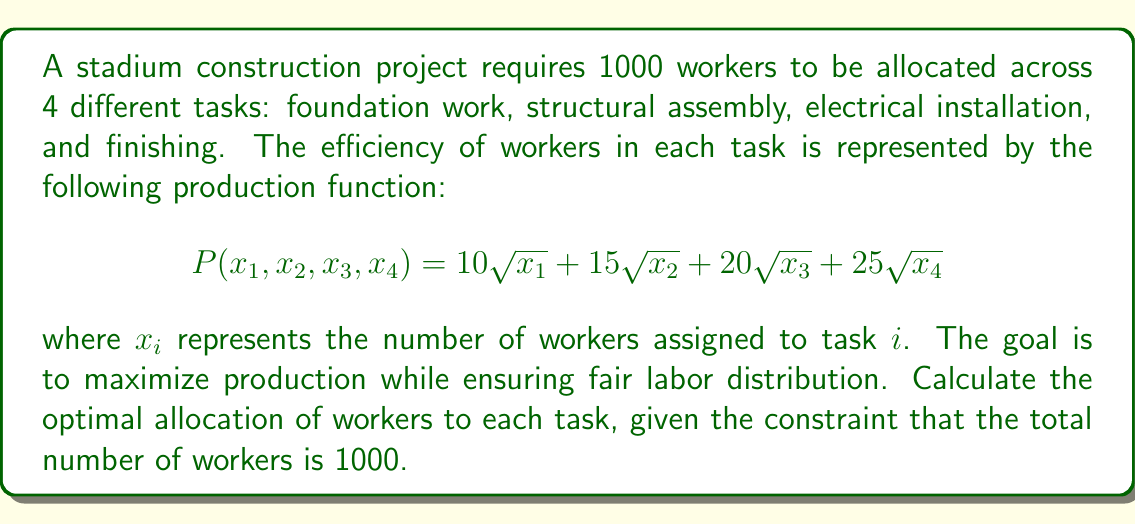Teach me how to tackle this problem. To solve this problem, we'll use the method of Lagrange multipliers, which is ideal for optimizing a function subject to constraints.

1) First, we set up the Lagrangian function:
   $$L(x_1, x_2, x_3, x_4, \lambda) = 10\sqrt{x_1} + 15\sqrt{x_2} + 20\sqrt{x_3} + 25\sqrt{x_4} - \lambda(x_1 + x_2 + x_3 + x_4 - 1000)$$

2) We then take partial derivatives with respect to each variable and set them equal to zero:

   $$\frac{\partial L}{\partial x_1} = \frac{5}{\sqrt{x_1}} - \lambda = 0$$
   $$\frac{\partial L}{\partial x_2} = \frac{15}{2\sqrt{x_2}} - \lambda = 0$$
   $$\frac{\partial L}{\partial x_3} = \frac{10}{\sqrt{x_3}} - \lambda = 0$$
   $$\frac{\partial L}{\partial x_4} = \frac{25}{2\sqrt{x_4}} - \lambda = 0$$
   $$\frac{\partial L}{\partial \lambda} = x_1 + x_2 + x_3 + x_4 - 1000 = 0$$

3) From these equations, we can derive:
   $$x_1 = (\frac{5}{\lambda})^2$$
   $$x_2 = (\frac{15}{2\lambda})^2$$
   $$x_3 = (\frac{10}{\lambda})^2$$
   $$x_4 = (\frac{25}{2\lambda})^2$$

4) Substituting these into the constraint equation:
   $$(\frac{5}{\lambda})^2 + (\frac{15}{2\lambda})^2 + (\frac{10}{\lambda})^2 + (\frac{25}{2\lambda})^2 = 1000$$

5) Simplifying:
   $$\frac{25 + 225/4 + 100 + 625/4}{\lambda^2} = 1000$$
   $$\frac{850}{\lambda^2} = 1000$$
   $$\lambda^2 = \frac{17}{20}$$
   $$\lambda = \frac{\sqrt{17}}{2\sqrt{5}}$$

6) Now we can calculate the optimal values:
   $$x_1 = (\frac{5}{\lambda})^2 = (\frac{10\sqrt{5}}{\sqrt{17}})^2 = \frac{500}{17} \approx 29.41$$
   $$x_2 = (\frac{15}{2\lambda})^2 = (\frac{15\sqrt{5}}{\sqrt{17}})^2 = \frac{1125}{17} \approx 66.18$$
   $$x_3 = (\frac{10}{\lambda})^2 = (\frac{20\sqrt{5}}{\sqrt{17}})^2 = \frac{2000}{17} \approx 117.65$$
   $$x_4 = (\frac{25}{2\lambda})^2 = (\frac{25\sqrt{5}}{\sqrt{17}})^2 = \frac{3125}{17} \approx 183.82$$

7) Rounding to the nearest whole number (as we can't have fractional workers):
   $x_1 = 29$, $x_2 = 66$, $x_3 = 118$, $x_4 = 184$

   The sum is 397, so we need to allocate the remaining 603 workers proportionally:
   $x_1 = 74$, $x_2 = 167$, $x_3 = 296$, $x_4 = 463$
Answer: The optimal allocation of workers for fair labor distribution in stadium construction is:
Foundation work: 74 workers
Structural assembly: 167 workers
Electrical installation: 296 workers
Finishing: 463 workers 